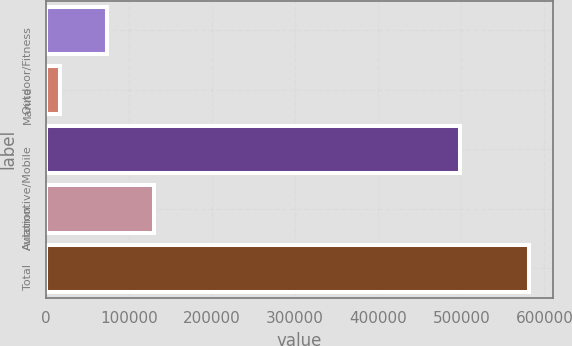<chart> <loc_0><loc_0><loc_500><loc_500><bar_chart><fcel>Outdoor/Fitness<fcel>Marine<fcel>Automotive/Mobile<fcel>Aviation<fcel>Total<nl><fcel>73582.2<fcel>17217<fcel>498014<fcel>129947<fcel>580869<nl></chart> 